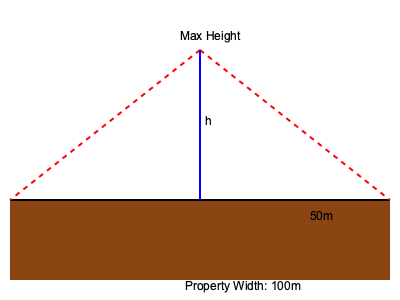Based on the cross-sectional view of a property, calculate the maximum allowable building height (h) if local regulations stipulate that no part of the structure can extend beyond a 45-degree angle from the property line. The property width is 100 meters, and the building must maintain a minimum setback of 25 meters from each side. Round your answer to the nearest meter. To solve this problem, we'll follow these steps:

1) First, we need to understand the geometry of the situation. The 45-degree angle restriction forms a right triangle from the property line to the maximum height point.

2) The property is 100m wide, with a 25m setback on each side. This means the buildable width is:
   $100m - (25m \times 2) = 50m$

3) In a right triangle with a 45-degree angle, the opposite and adjacent sides are equal. This means the maximum height will be equal to half the buildable width.

4) We can express this mathematically:
   $h = \frac{50m}{2} = 25m$

5) The question asks to round to the nearest meter, but 25m is already a whole number, so no rounding is necessary.

Therefore, the maximum allowable building height is 25 meters.
Answer: 25 meters 